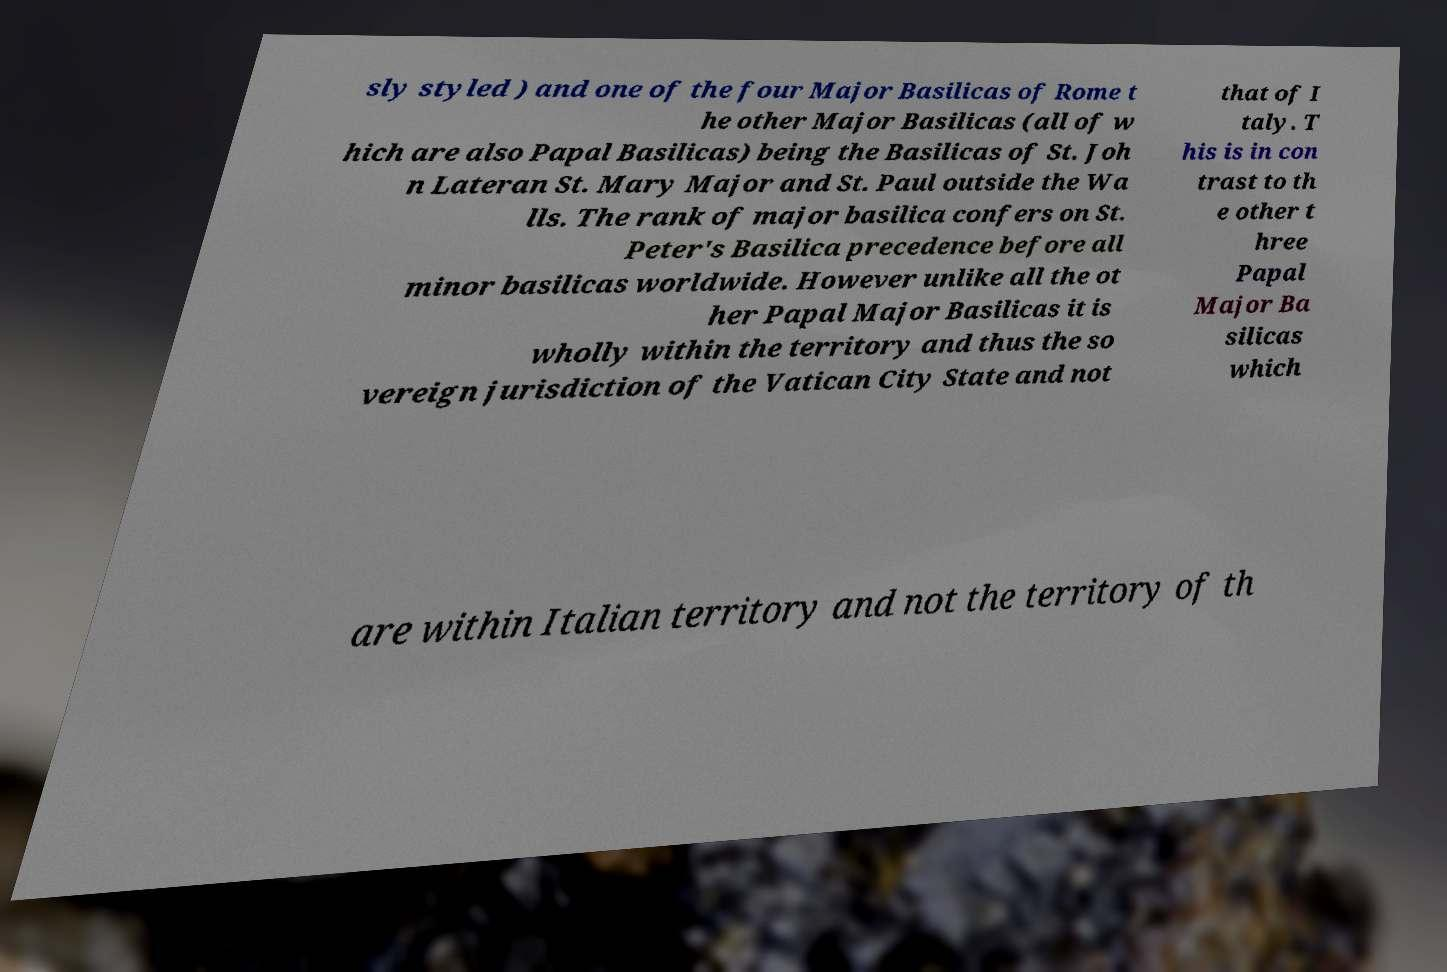Can you read and provide the text displayed in the image?This photo seems to have some interesting text. Can you extract and type it out for me? sly styled ) and one of the four Major Basilicas of Rome t he other Major Basilicas (all of w hich are also Papal Basilicas) being the Basilicas of St. Joh n Lateran St. Mary Major and St. Paul outside the Wa lls. The rank of major basilica confers on St. Peter's Basilica precedence before all minor basilicas worldwide. However unlike all the ot her Papal Major Basilicas it is wholly within the territory and thus the so vereign jurisdiction of the Vatican City State and not that of I taly. T his is in con trast to th e other t hree Papal Major Ba silicas which are within Italian territory and not the territory of th 